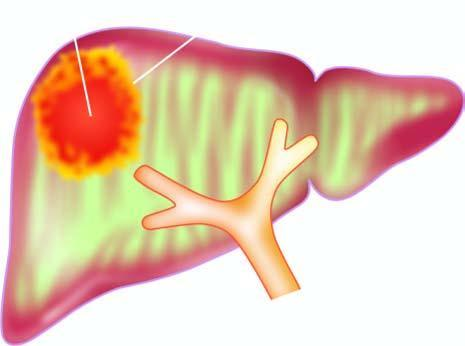what is commonly solitary?
Answer the question using a single word or phrase. Moebic liver abscess 